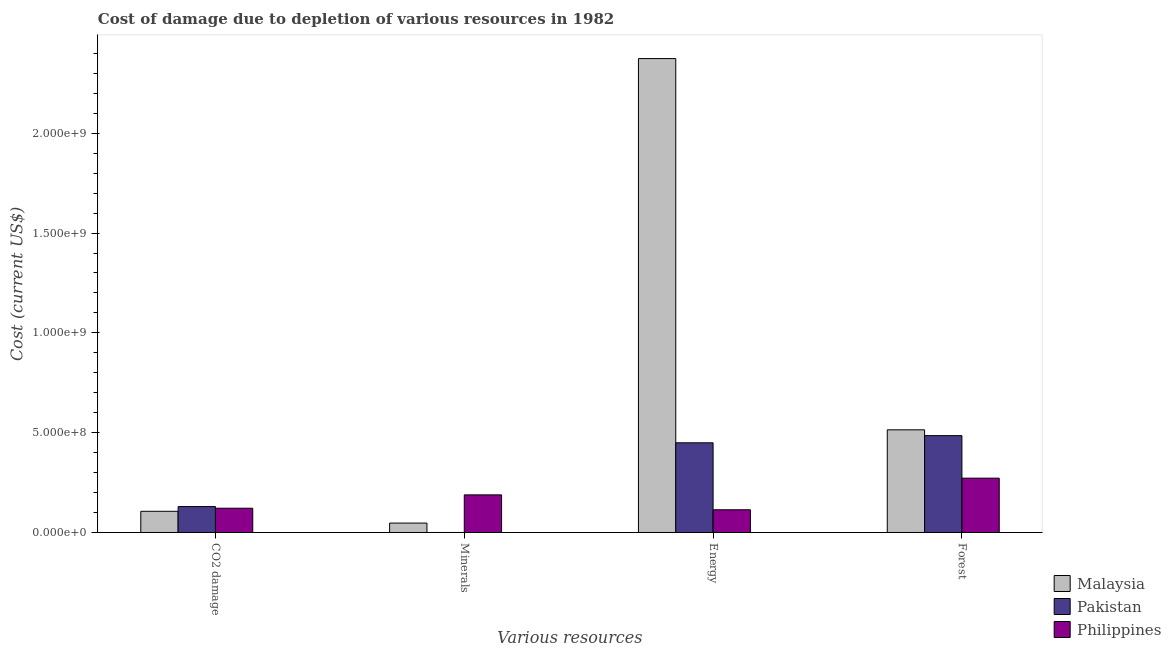How many different coloured bars are there?
Provide a short and direct response. 3. How many groups of bars are there?
Give a very brief answer. 4. Are the number of bars per tick equal to the number of legend labels?
Keep it short and to the point. Yes. How many bars are there on the 1st tick from the right?
Give a very brief answer. 3. What is the label of the 4th group of bars from the left?
Provide a short and direct response. Forest. What is the cost of damage due to depletion of forests in Pakistan?
Offer a terse response. 4.85e+08. Across all countries, what is the maximum cost of damage due to depletion of forests?
Make the answer very short. 5.14e+08. Across all countries, what is the minimum cost of damage due to depletion of coal?
Your answer should be very brief. 1.06e+08. In which country was the cost of damage due to depletion of energy maximum?
Provide a short and direct response. Malaysia. In which country was the cost of damage due to depletion of minerals minimum?
Keep it short and to the point. Pakistan. What is the total cost of damage due to depletion of coal in the graph?
Give a very brief answer. 3.58e+08. What is the difference between the cost of damage due to depletion of minerals in Pakistan and that in Philippines?
Provide a short and direct response. -1.88e+08. What is the difference between the cost of damage due to depletion of minerals in Philippines and the cost of damage due to depletion of energy in Malaysia?
Offer a terse response. -2.19e+09. What is the average cost of damage due to depletion of forests per country?
Provide a succinct answer. 4.24e+08. What is the difference between the cost of damage due to depletion of minerals and cost of damage due to depletion of energy in Philippines?
Offer a terse response. 7.47e+07. In how many countries, is the cost of damage due to depletion of coal greater than 800000000 US$?
Provide a succinct answer. 0. What is the ratio of the cost of damage due to depletion of forests in Malaysia to that in Philippines?
Provide a succinct answer. 1.89. What is the difference between the highest and the second highest cost of damage due to depletion of minerals?
Your answer should be very brief. 1.41e+08. What is the difference between the highest and the lowest cost of damage due to depletion of energy?
Make the answer very short. 2.26e+09. Is it the case that in every country, the sum of the cost of damage due to depletion of forests and cost of damage due to depletion of coal is greater than the sum of cost of damage due to depletion of energy and cost of damage due to depletion of minerals?
Provide a short and direct response. Yes. What does the 3rd bar from the left in CO2 damage represents?
Offer a terse response. Philippines. What does the 3rd bar from the right in Forest represents?
Provide a short and direct response. Malaysia. How many bars are there?
Your answer should be compact. 12. Are all the bars in the graph horizontal?
Provide a short and direct response. No. Does the graph contain any zero values?
Make the answer very short. No. Does the graph contain grids?
Keep it short and to the point. No. Where does the legend appear in the graph?
Offer a very short reply. Bottom right. How many legend labels are there?
Provide a succinct answer. 3. What is the title of the graph?
Offer a very short reply. Cost of damage due to depletion of various resources in 1982 . Does "Antigua and Barbuda" appear as one of the legend labels in the graph?
Keep it short and to the point. No. What is the label or title of the X-axis?
Your response must be concise. Various resources. What is the label or title of the Y-axis?
Provide a succinct answer. Cost (current US$). What is the Cost (current US$) in Malaysia in CO2 damage?
Keep it short and to the point. 1.06e+08. What is the Cost (current US$) of Pakistan in CO2 damage?
Provide a short and direct response. 1.30e+08. What is the Cost (current US$) of Philippines in CO2 damage?
Offer a terse response. 1.22e+08. What is the Cost (current US$) of Malaysia in Minerals?
Your answer should be compact. 4.71e+07. What is the Cost (current US$) of Pakistan in Minerals?
Offer a terse response. 4.41e+04. What is the Cost (current US$) of Philippines in Minerals?
Provide a succinct answer. 1.88e+08. What is the Cost (current US$) in Malaysia in Energy?
Provide a succinct answer. 2.37e+09. What is the Cost (current US$) of Pakistan in Energy?
Offer a terse response. 4.49e+08. What is the Cost (current US$) of Philippines in Energy?
Ensure brevity in your answer.  1.14e+08. What is the Cost (current US$) of Malaysia in Forest?
Provide a succinct answer. 5.14e+08. What is the Cost (current US$) in Pakistan in Forest?
Make the answer very short. 4.85e+08. What is the Cost (current US$) in Philippines in Forest?
Your answer should be compact. 2.72e+08. Across all Various resources, what is the maximum Cost (current US$) in Malaysia?
Give a very brief answer. 2.37e+09. Across all Various resources, what is the maximum Cost (current US$) of Pakistan?
Ensure brevity in your answer.  4.85e+08. Across all Various resources, what is the maximum Cost (current US$) of Philippines?
Ensure brevity in your answer.  2.72e+08. Across all Various resources, what is the minimum Cost (current US$) of Malaysia?
Make the answer very short. 4.71e+07. Across all Various resources, what is the minimum Cost (current US$) in Pakistan?
Keep it short and to the point. 4.41e+04. Across all Various resources, what is the minimum Cost (current US$) of Philippines?
Keep it short and to the point. 1.14e+08. What is the total Cost (current US$) in Malaysia in the graph?
Keep it short and to the point. 3.04e+09. What is the total Cost (current US$) of Pakistan in the graph?
Keep it short and to the point. 1.06e+09. What is the total Cost (current US$) in Philippines in the graph?
Provide a succinct answer. 6.96e+08. What is the difference between the Cost (current US$) of Malaysia in CO2 damage and that in Minerals?
Offer a terse response. 5.90e+07. What is the difference between the Cost (current US$) of Pakistan in CO2 damage and that in Minerals?
Your response must be concise. 1.30e+08. What is the difference between the Cost (current US$) of Philippines in CO2 damage and that in Minerals?
Make the answer very short. -6.69e+07. What is the difference between the Cost (current US$) in Malaysia in CO2 damage and that in Energy?
Offer a very short reply. -2.27e+09. What is the difference between the Cost (current US$) in Pakistan in CO2 damage and that in Energy?
Your response must be concise. -3.19e+08. What is the difference between the Cost (current US$) in Philippines in CO2 damage and that in Energy?
Offer a terse response. 7.80e+06. What is the difference between the Cost (current US$) of Malaysia in CO2 damage and that in Forest?
Offer a very short reply. -4.08e+08. What is the difference between the Cost (current US$) of Pakistan in CO2 damage and that in Forest?
Provide a short and direct response. -3.55e+08. What is the difference between the Cost (current US$) in Philippines in CO2 damage and that in Forest?
Provide a short and direct response. -1.51e+08. What is the difference between the Cost (current US$) of Malaysia in Minerals and that in Energy?
Give a very brief answer. -2.33e+09. What is the difference between the Cost (current US$) of Pakistan in Minerals and that in Energy?
Your answer should be compact. -4.49e+08. What is the difference between the Cost (current US$) in Philippines in Minerals and that in Energy?
Give a very brief answer. 7.47e+07. What is the difference between the Cost (current US$) in Malaysia in Minerals and that in Forest?
Your answer should be compact. -4.67e+08. What is the difference between the Cost (current US$) of Pakistan in Minerals and that in Forest?
Give a very brief answer. -4.85e+08. What is the difference between the Cost (current US$) of Philippines in Minerals and that in Forest?
Give a very brief answer. -8.37e+07. What is the difference between the Cost (current US$) of Malaysia in Energy and that in Forest?
Your answer should be very brief. 1.86e+09. What is the difference between the Cost (current US$) in Pakistan in Energy and that in Forest?
Make the answer very short. -3.59e+07. What is the difference between the Cost (current US$) in Philippines in Energy and that in Forest?
Your response must be concise. -1.58e+08. What is the difference between the Cost (current US$) in Malaysia in CO2 damage and the Cost (current US$) in Pakistan in Minerals?
Your answer should be compact. 1.06e+08. What is the difference between the Cost (current US$) of Malaysia in CO2 damage and the Cost (current US$) of Philippines in Minerals?
Make the answer very short. -8.22e+07. What is the difference between the Cost (current US$) in Pakistan in CO2 damage and the Cost (current US$) in Philippines in Minerals?
Your response must be concise. -5.86e+07. What is the difference between the Cost (current US$) in Malaysia in CO2 damage and the Cost (current US$) in Pakistan in Energy?
Your response must be concise. -3.43e+08. What is the difference between the Cost (current US$) of Malaysia in CO2 damage and the Cost (current US$) of Philippines in Energy?
Your answer should be compact. -7.57e+06. What is the difference between the Cost (current US$) of Pakistan in CO2 damage and the Cost (current US$) of Philippines in Energy?
Your answer should be very brief. 1.61e+07. What is the difference between the Cost (current US$) of Malaysia in CO2 damage and the Cost (current US$) of Pakistan in Forest?
Make the answer very short. -3.79e+08. What is the difference between the Cost (current US$) of Malaysia in CO2 damage and the Cost (current US$) of Philippines in Forest?
Ensure brevity in your answer.  -1.66e+08. What is the difference between the Cost (current US$) in Pakistan in CO2 damage and the Cost (current US$) in Philippines in Forest?
Your answer should be compact. -1.42e+08. What is the difference between the Cost (current US$) in Malaysia in Minerals and the Cost (current US$) in Pakistan in Energy?
Ensure brevity in your answer.  -4.02e+08. What is the difference between the Cost (current US$) of Malaysia in Minerals and the Cost (current US$) of Philippines in Energy?
Make the answer very short. -6.66e+07. What is the difference between the Cost (current US$) in Pakistan in Minerals and the Cost (current US$) in Philippines in Energy?
Provide a short and direct response. -1.14e+08. What is the difference between the Cost (current US$) of Malaysia in Minerals and the Cost (current US$) of Pakistan in Forest?
Provide a short and direct response. -4.38e+08. What is the difference between the Cost (current US$) of Malaysia in Minerals and the Cost (current US$) of Philippines in Forest?
Your answer should be compact. -2.25e+08. What is the difference between the Cost (current US$) of Pakistan in Minerals and the Cost (current US$) of Philippines in Forest?
Provide a succinct answer. -2.72e+08. What is the difference between the Cost (current US$) of Malaysia in Energy and the Cost (current US$) of Pakistan in Forest?
Keep it short and to the point. 1.89e+09. What is the difference between the Cost (current US$) of Malaysia in Energy and the Cost (current US$) of Philippines in Forest?
Your answer should be compact. 2.10e+09. What is the difference between the Cost (current US$) of Pakistan in Energy and the Cost (current US$) of Philippines in Forest?
Keep it short and to the point. 1.77e+08. What is the average Cost (current US$) in Malaysia per Various resources?
Your answer should be compact. 7.60e+08. What is the average Cost (current US$) of Pakistan per Various resources?
Ensure brevity in your answer.  2.66e+08. What is the average Cost (current US$) in Philippines per Various resources?
Provide a succinct answer. 1.74e+08. What is the difference between the Cost (current US$) of Malaysia and Cost (current US$) of Pakistan in CO2 damage?
Your answer should be compact. -2.37e+07. What is the difference between the Cost (current US$) of Malaysia and Cost (current US$) of Philippines in CO2 damage?
Provide a short and direct response. -1.54e+07. What is the difference between the Cost (current US$) in Pakistan and Cost (current US$) in Philippines in CO2 damage?
Offer a very short reply. 8.29e+06. What is the difference between the Cost (current US$) of Malaysia and Cost (current US$) of Pakistan in Minerals?
Your response must be concise. 4.71e+07. What is the difference between the Cost (current US$) in Malaysia and Cost (current US$) in Philippines in Minerals?
Your answer should be very brief. -1.41e+08. What is the difference between the Cost (current US$) in Pakistan and Cost (current US$) in Philippines in Minerals?
Provide a succinct answer. -1.88e+08. What is the difference between the Cost (current US$) of Malaysia and Cost (current US$) of Pakistan in Energy?
Your response must be concise. 1.92e+09. What is the difference between the Cost (current US$) in Malaysia and Cost (current US$) in Philippines in Energy?
Your answer should be very brief. 2.26e+09. What is the difference between the Cost (current US$) in Pakistan and Cost (current US$) in Philippines in Energy?
Make the answer very short. 3.36e+08. What is the difference between the Cost (current US$) in Malaysia and Cost (current US$) in Pakistan in Forest?
Provide a short and direct response. 2.91e+07. What is the difference between the Cost (current US$) of Malaysia and Cost (current US$) of Philippines in Forest?
Your response must be concise. 2.42e+08. What is the difference between the Cost (current US$) in Pakistan and Cost (current US$) in Philippines in Forest?
Provide a short and direct response. 2.13e+08. What is the ratio of the Cost (current US$) in Malaysia in CO2 damage to that in Minerals?
Provide a short and direct response. 2.25. What is the ratio of the Cost (current US$) of Pakistan in CO2 damage to that in Minerals?
Give a very brief answer. 2942.22. What is the ratio of the Cost (current US$) in Philippines in CO2 damage to that in Minerals?
Provide a short and direct response. 0.65. What is the ratio of the Cost (current US$) in Malaysia in CO2 damage to that in Energy?
Provide a short and direct response. 0.04. What is the ratio of the Cost (current US$) of Pakistan in CO2 damage to that in Energy?
Offer a very short reply. 0.29. What is the ratio of the Cost (current US$) of Philippines in CO2 damage to that in Energy?
Your answer should be compact. 1.07. What is the ratio of the Cost (current US$) of Malaysia in CO2 damage to that in Forest?
Offer a very short reply. 0.21. What is the ratio of the Cost (current US$) of Pakistan in CO2 damage to that in Forest?
Keep it short and to the point. 0.27. What is the ratio of the Cost (current US$) of Philippines in CO2 damage to that in Forest?
Provide a short and direct response. 0.45. What is the ratio of the Cost (current US$) in Malaysia in Minerals to that in Energy?
Make the answer very short. 0.02. What is the ratio of the Cost (current US$) of Philippines in Minerals to that in Energy?
Make the answer very short. 1.66. What is the ratio of the Cost (current US$) in Malaysia in Minerals to that in Forest?
Your answer should be very brief. 0.09. What is the ratio of the Cost (current US$) in Pakistan in Minerals to that in Forest?
Keep it short and to the point. 0. What is the ratio of the Cost (current US$) of Philippines in Minerals to that in Forest?
Your answer should be compact. 0.69. What is the ratio of the Cost (current US$) of Malaysia in Energy to that in Forest?
Offer a very short reply. 4.62. What is the ratio of the Cost (current US$) in Pakistan in Energy to that in Forest?
Keep it short and to the point. 0.93. What is the ratio of the Cost (current US$) in Philippines in Energy to that in Forest?
Provide a short and direct response. 0.42. What is the difference between the highest and the second highest Cost (current US$) in Malaysia?
Provide a succinct answer. 1.86e+09. What is the difference between the highest and the second highest Cost (current US$) of Pakistan?
Keep it short and to the point. 3.59e+07. What is the difference between the highest and the second highest Cost (current US$) of Philippines?
Provide a short and direct response. 8.37e+07. What is the difference between the highest and the lowest Cost (current US$) in Malaysia?
Give a very brief answer. 2.33e+09. What is the difference between the highest and the lowest Cost (current US$) of Pakistan?
Provide a succinct answer. 4.85e+08. What is the difference between the highest and the lowest Cost (current US$) in Philippines?
Your response must be concise. 1.58e+08. 